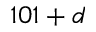Convert formula to latex. <formula><loc_0><loc_0><loc_500><loc_500>1 0 1 + d</formula> 